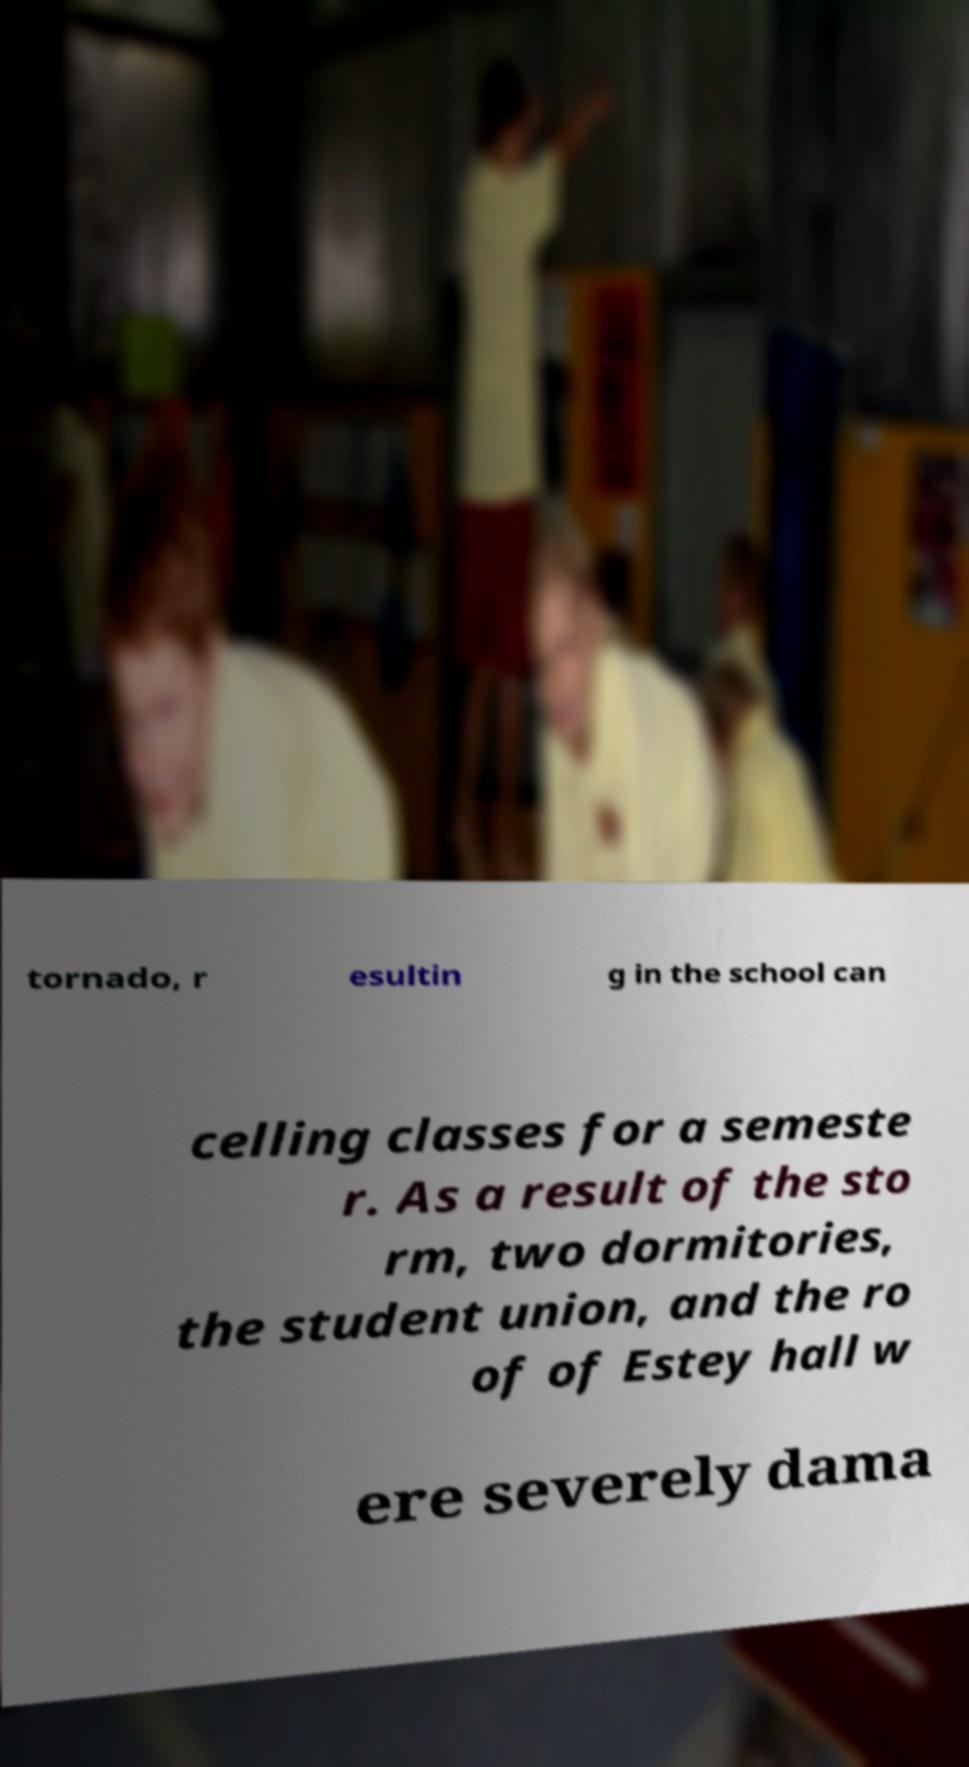Could you assist in decoding the text presented in this image and type it out clearly? tornado, r esultin g in the school can celling classes for a semeste r. As a result of the sto rm, two dormitories, the student union, and the ro of of Estey hall w ere severely dama 